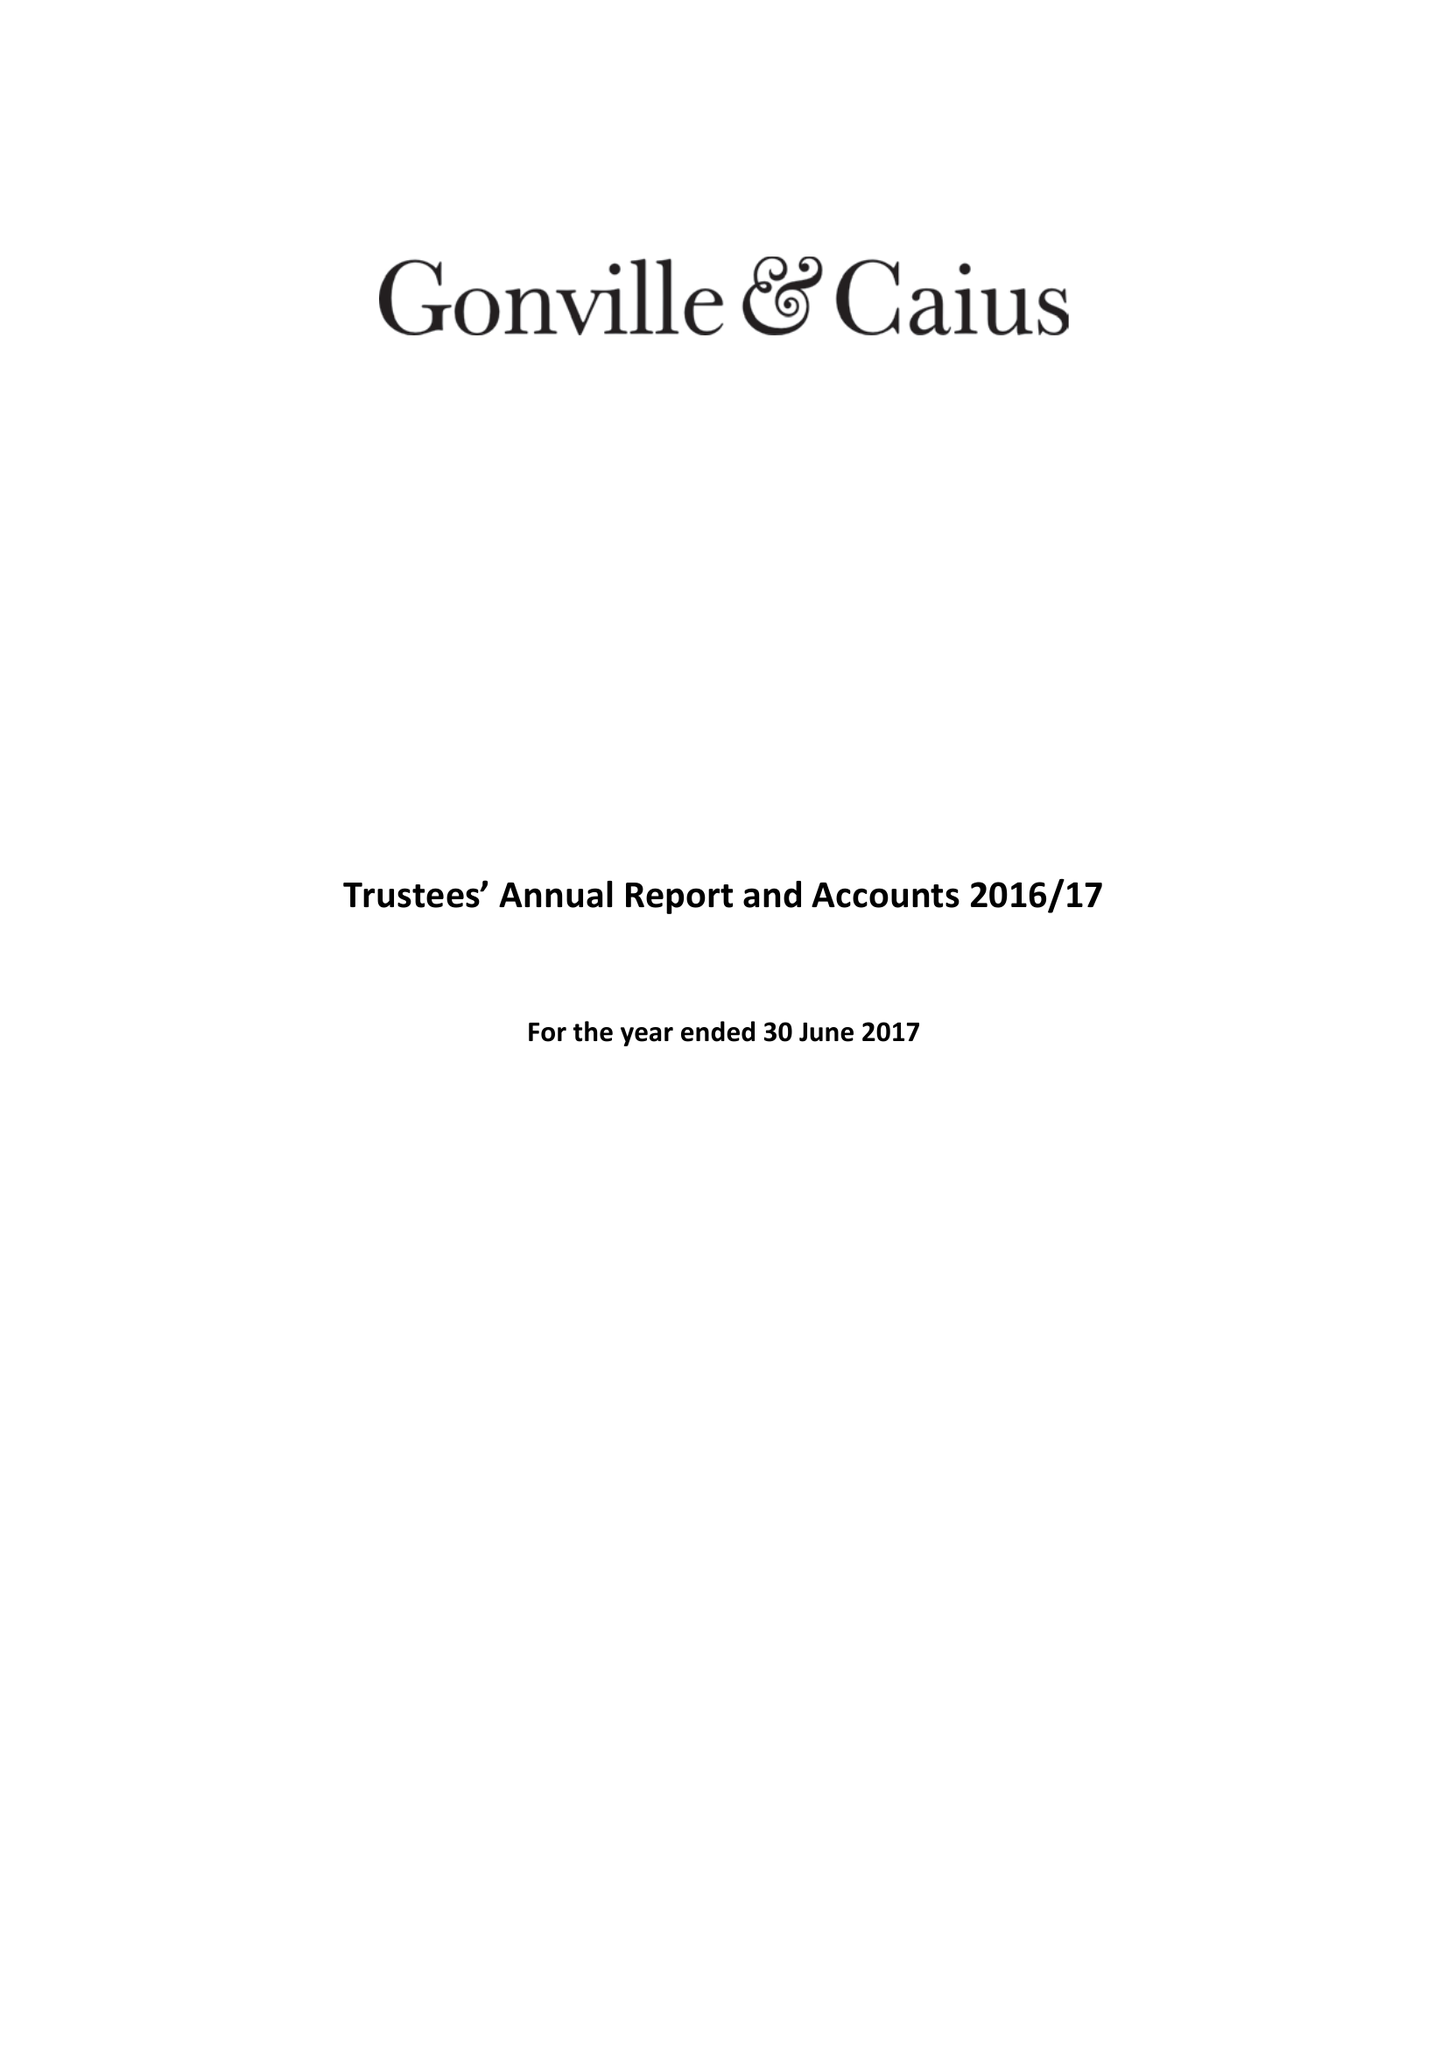What is the value for the income_annually_in_british_pounds?
Answer the question using a single word or phrase. 18361000.00 